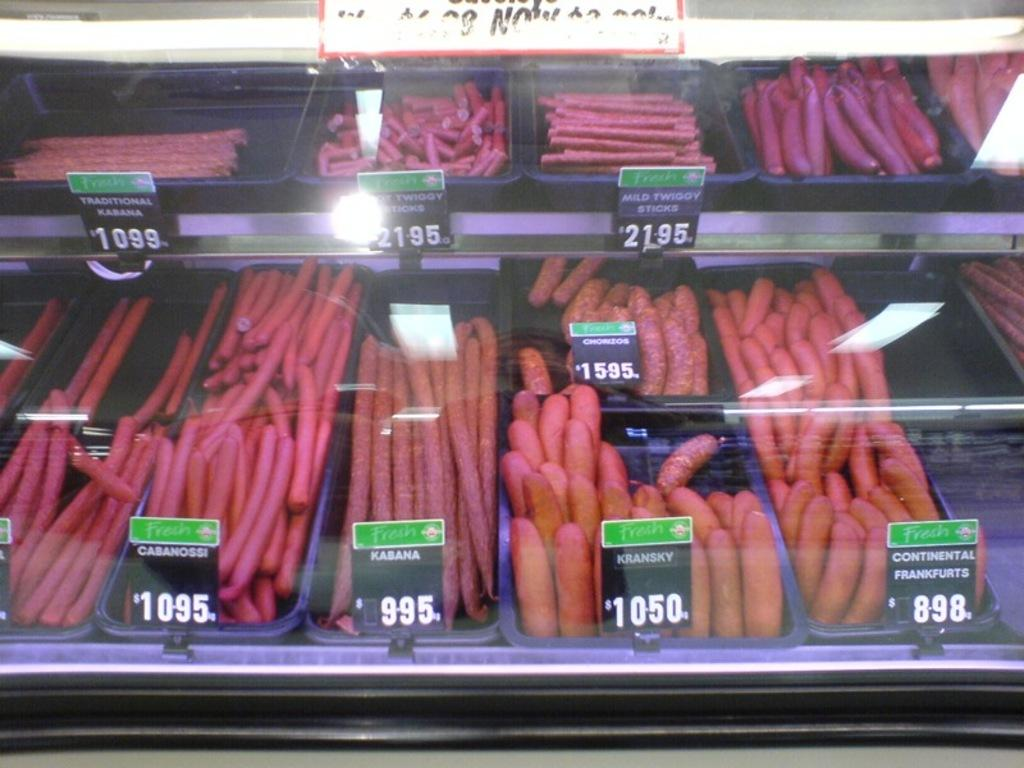What type of establishment is depicted in the image? There is a food place in the image. How are the different food items identified in the image? There are tags for each food in the image. What type of apparel is being sold at the food place in the image? There is no apparel being sold at the food place in the image; it is focused on food items. Can you tell me who the partner of the food place is in the image? There is no information about a partner of the food place in the image. 